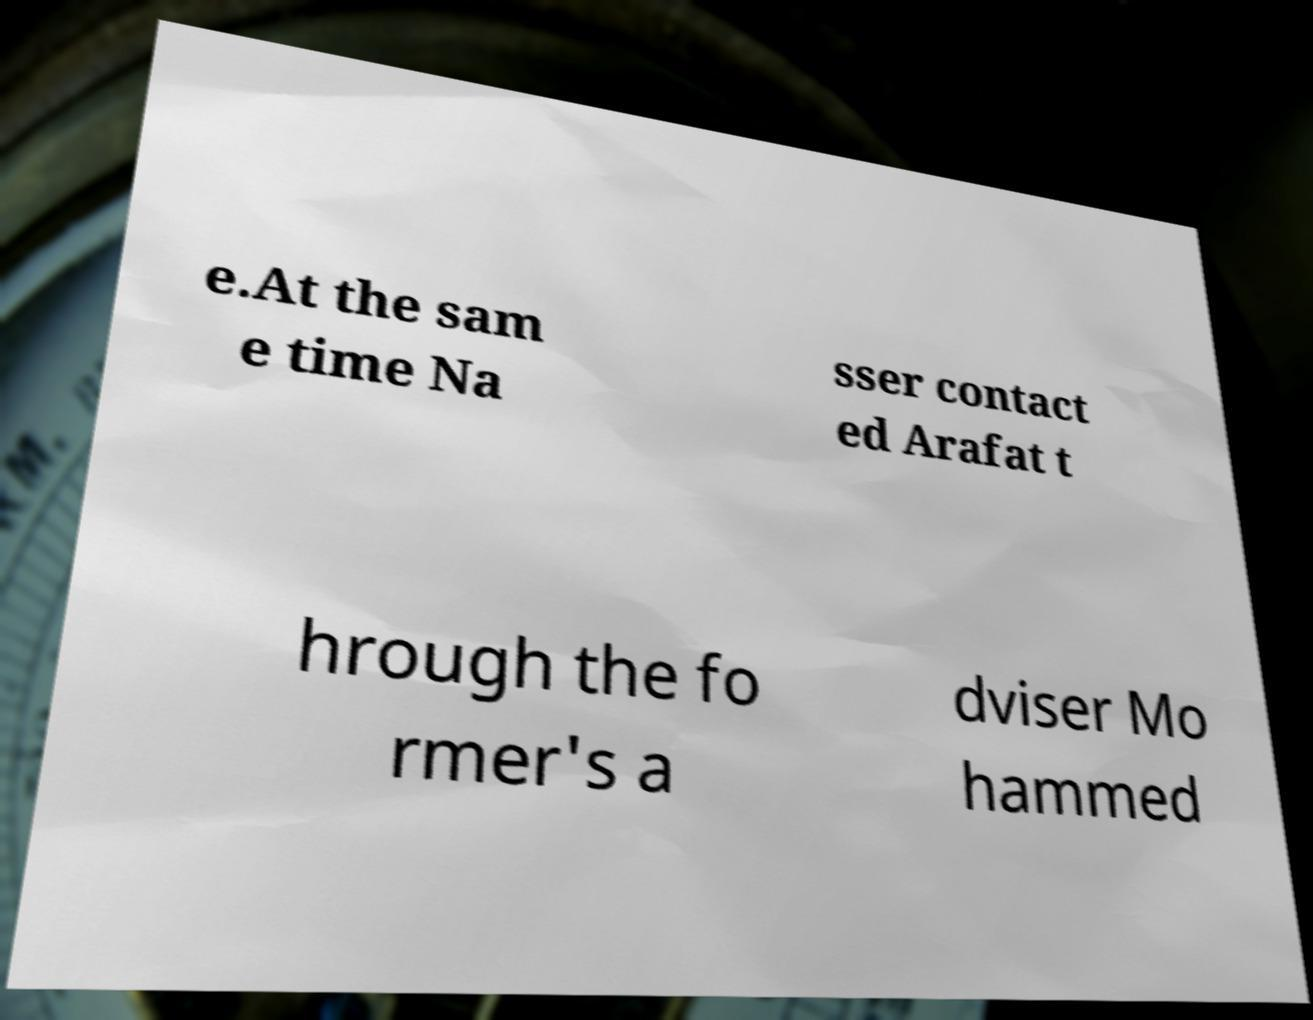There's text embedded in this image that I need extracted. Can you transcribe it verbatim? e.At the sam e time Na sser contact ed Arafat t hrough the fo rmer's a dviser Mo hammed 